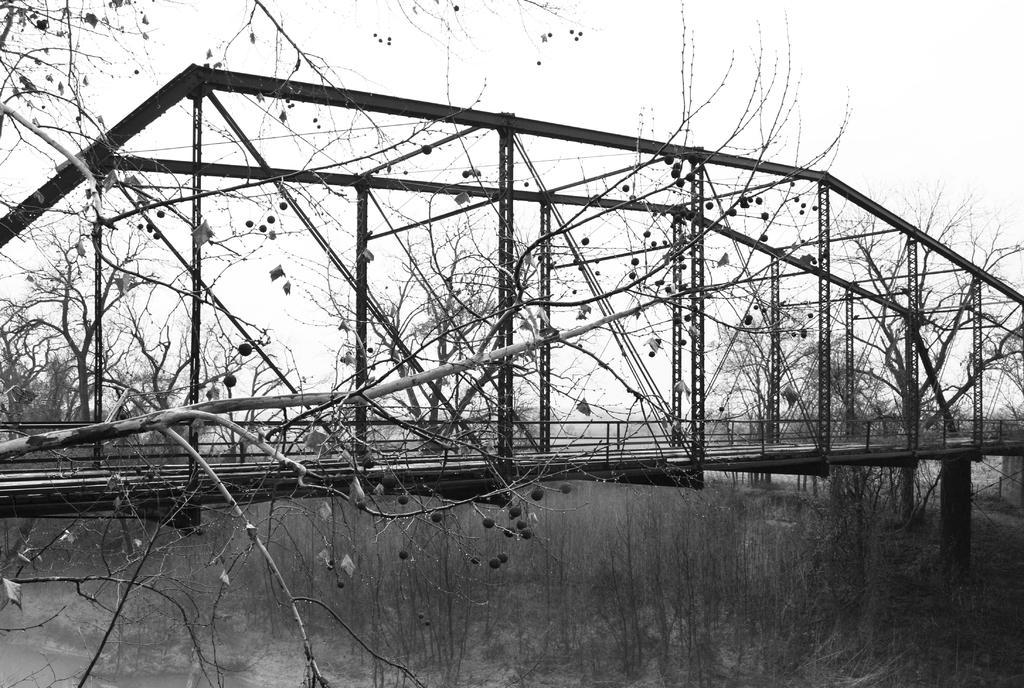Can you describe this image briefly? In this picture we can see a bridge in the front, we can see branches of the tree, in the background there are some trees, we can see the sky at the top of the picture, it is a black and white image. 